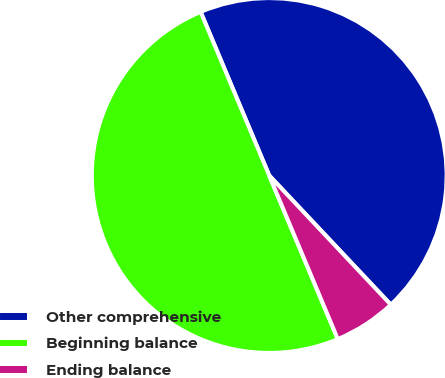<chart> <loc_0><loc_0><loc_500><loc_500><pie_chart><fcel>Other comprehensive<fcel>Beginning balance<fcel>Ending balance<nl><fcel>44.3%<fcel>50.0%<fcel>5.7%<nl></chart> 